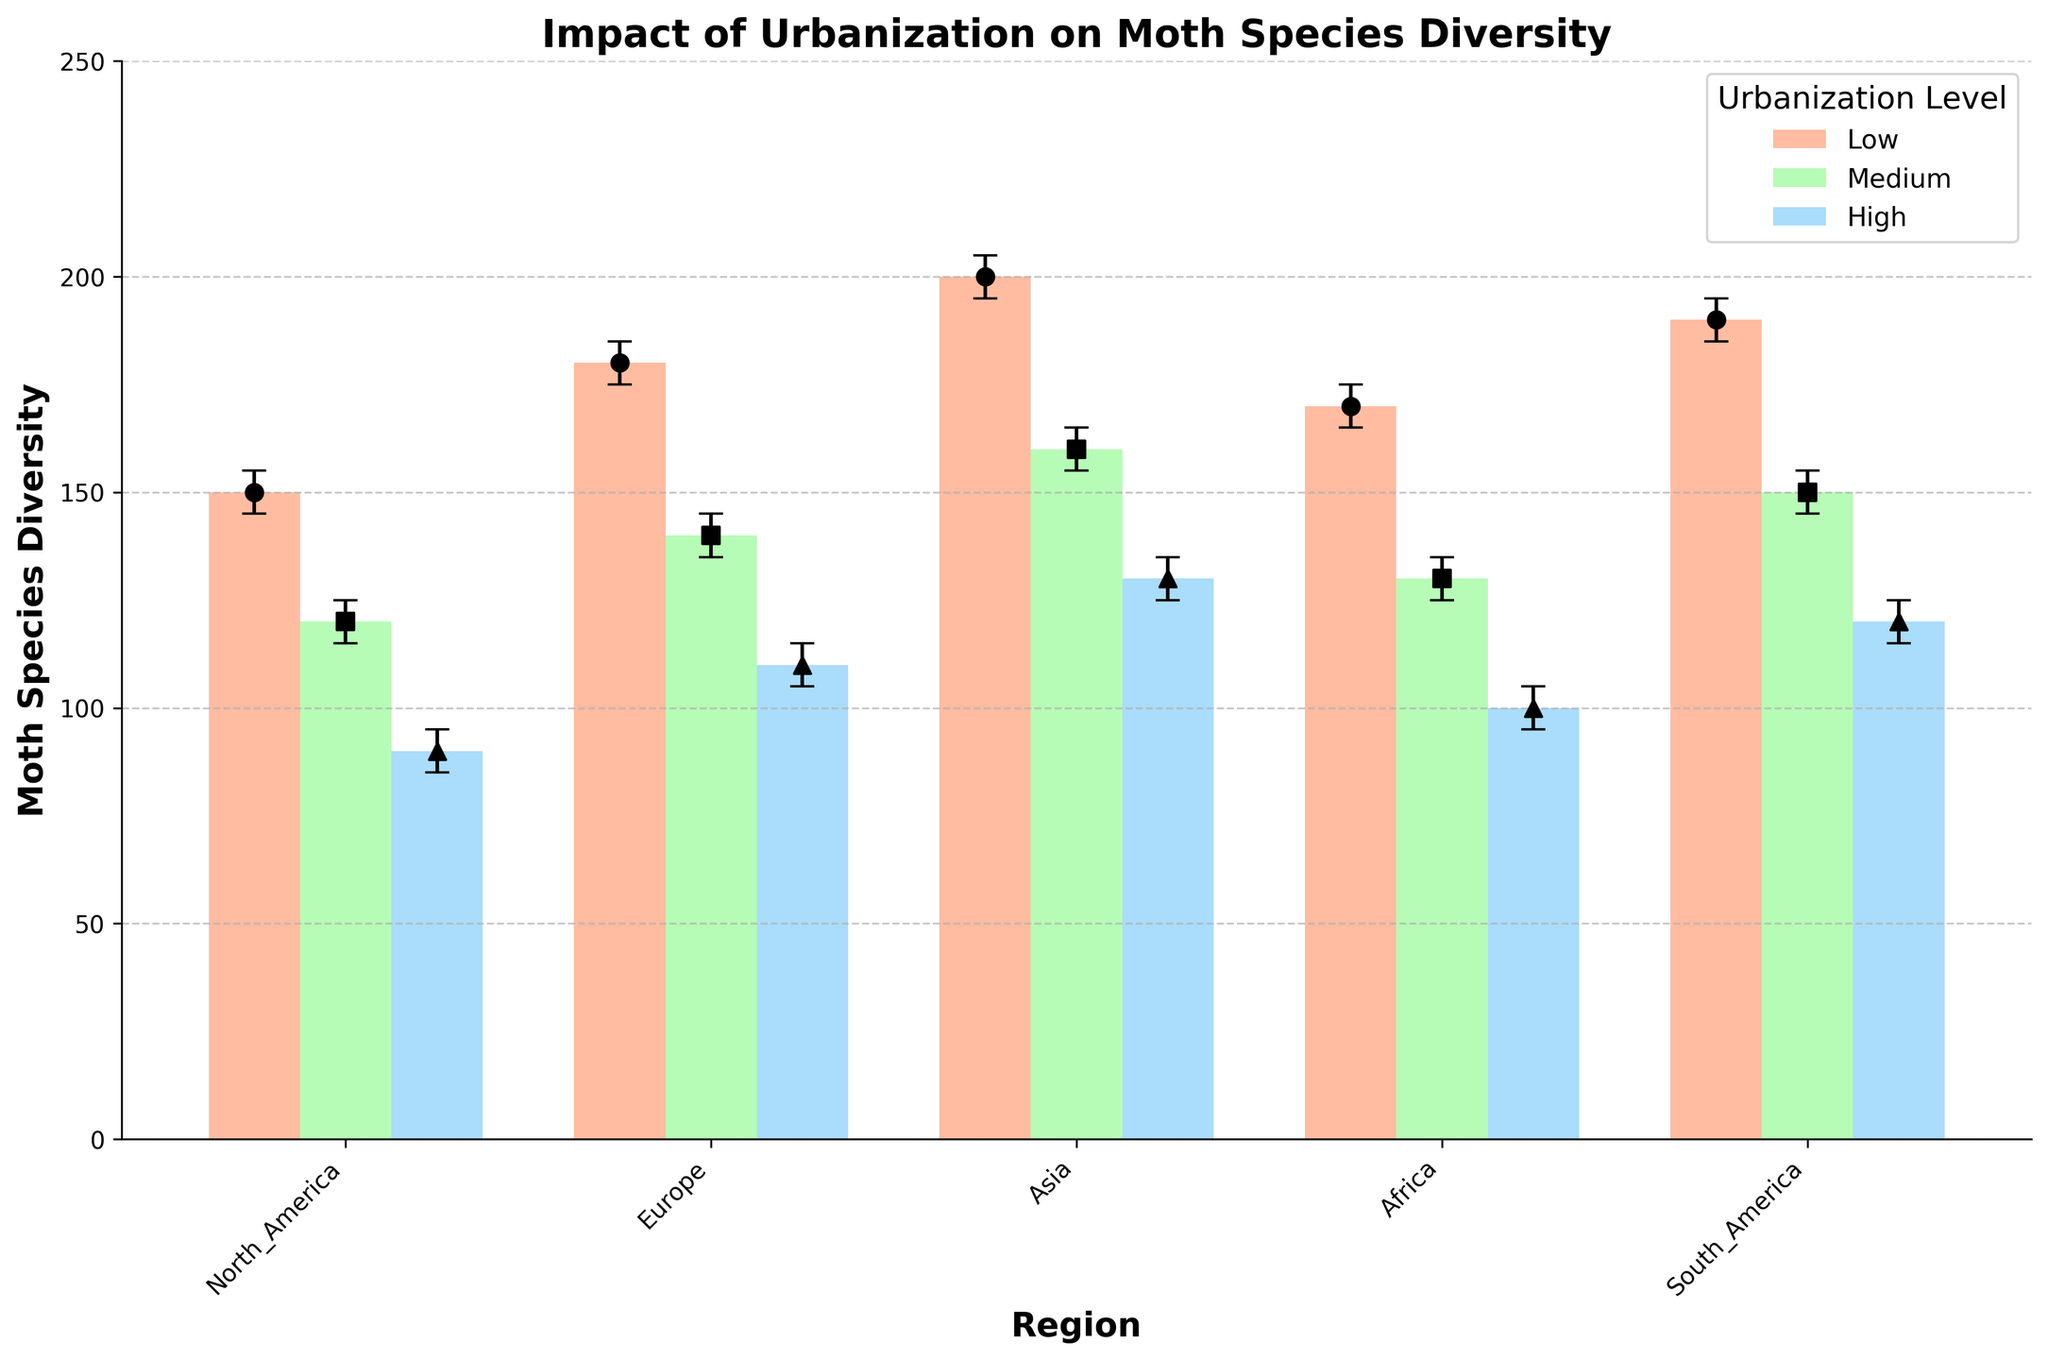What is the title of the figure? The title is displayed prominently at the top of the figure.
Answer: Impact of Urbanization on Moth Species Diversity Which region has the highest moth species diversity at low urbanization levels? By examining the height of the bars labeled 'Low', Asia has the highest bar indicating highest diversity.
Answer: Asia What is the difference in moth species diversity between medium and high urbanization levels in Europe? Subtract the species diversity value for high urbanization (110) from the medium urbanization (140).
Answer: 30 Which region shows the greatest decrease in moth species diversity from low to high urbanization levels? By comparing the difference between low and high urbanization levels across regions: North America (150-90=60), Europe (180-110=70), Asia (200-130=70), Africa (170-100=70), South America (190-120=70). Multiple regions have the greatest decrease.
Answer: Europe, Asia, Africa, South America What is the average moth species diversity across all urbanization levels in North America? Sum the diversity values across low, medium, and high urbanization levels (150 + 120 + 90 = 360), then divide by 3.
Answer: 120 Which regions have confidence intervals that do not overlap for medium urbanization levels? Non-overlapping intervals can be found by ensuring one interval’s upper bound is below the other’s lower bound. North America (115-125), Europe (135-145), Asia (155-165). These intervals do not overlap.
Answer: North America and Asia How does the moth species diversity at high urbanization levels in South America compare to low urbanization levels in North America? Compare the height of the 'High' bar in South America (120) with the 'Low' bar in North America (150).
Answer: Lower Across all regions, which urbanization level generally has the highest confidence in the data, until the CI range is smallest? Inspect the error bars for the shortest length range. Generally, the 'Low' urbanization levels have narrowest confidence intervals.
Answer: Low 